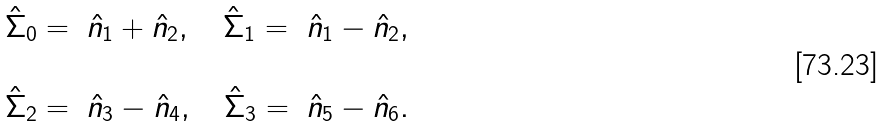Convert formula to latex. <formula><loc_0><loc_0><loc_500><loc_500>\begin{array} { r l l l } \hat { \Sigma } _ { 0 } = & \hat { n } _ { 1 } + \hat { n } _ { 2 } , \quad \hat { \Sigma } _ { 1 } = & \hat { n } _ { 1 } - \hat { n } _ { 2 } , \\ \\ \hat { \Sigma } _ { 2 } = & \hat { n } _ { 3 } - \hat { n } _ { 4 } , \quad \hat { \Sigma } _ { 3 } = & \hat { n } _ { 5 } - \hat { n } _ { 6 } . \\ \end{array}</formula> 